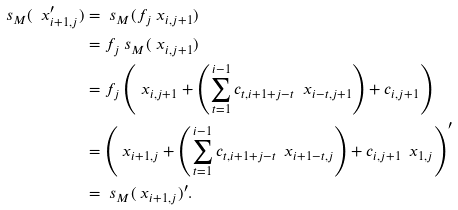<formula> <loc_0><loc_0><loc_500><loc_500>\ s _ { M } ( \ x ^ { \prime } _ { i + 1 , j } ) & = \ s _ { M } ( f _ { j } \ x _ { i , j + 1 } ) \\ & = f _ { j } \ s _ { M } ( \ x _ { i , j + 1 } ) \\ & = f _ { j } \left ( \ x _ { i , j + 1 } + \left ( \sum ^ { i - 1 } _ { t = 1 } c _ { t , i + 1 + j - t } \ \ x _ { i - t , j + 1 } \right ) + c _ { i , j + 1 } \right ) \\ & = \left ( \ x _ { i + 1 , j } + \left ( \sum ^ { i - 1 } _ { t = 1 } c _ { t , i + 1 + j - t } \ \ x _ { i + 1 - t , j } \right ) + c _ { i , j + 1 } \ \ x _ { 1 , j } \right ) ^ { \prime } \\ & = \ s _ { M } ( \ x _ { i + 1 , j } ) ^ { \prime } .</formula> 